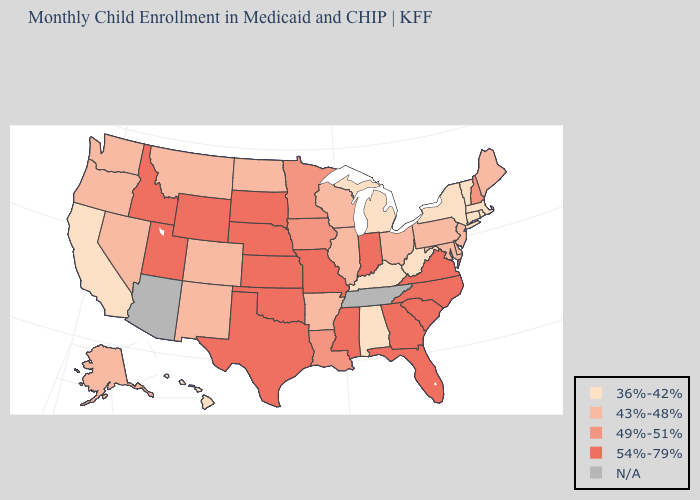Does Michigan have the lowest value in the MidWest?
Write a very short answer. Yes. What is the highest value in states that border Nebraska?
Concise answer only. 54%-79%. Does Nebraska have the highest value in the MidWest?
Answer briefly. Yes. Name the states that have a value in the range 49%-51%?
Concise answer only. Iowa, Louisiana, Minnesota, New Hampshire. Does the map have missing data?
Short answer required. Yes. Name the states that have a value in the range 54%-79%?
Give a very brief answer. Florida, Georgia, Idaho, Indiana, Kansas, Mississippi, Missouri, Nebraska, North Carolina, Oklahoma, South Carolina, South Dakota, Texas, Utah, Virginia, Wyoming. Which states have the lowest value in the USA?
Short answer required. Alabama, California, Connecticut, Hawaii, Kentucky, Massachusetts, Michigan, New York, Rhode Island, Vermont, West Virginia. What is the highest value in states that border Iowa?
Write a very short answer. 54%-79%. What is the value of Arizona?
Give a very brief answer. N/A. What is the lowest value in states that border North Dakota?
Keep it brief. 43%-48%. Name the states that have a value in the range 36%-42%?
Be succinct. Alabama, California, Connecticut, Hawaii, Kentucky, Massachusetts, Michigan, New York, Rhode Island, Vermont, West Virginia. 